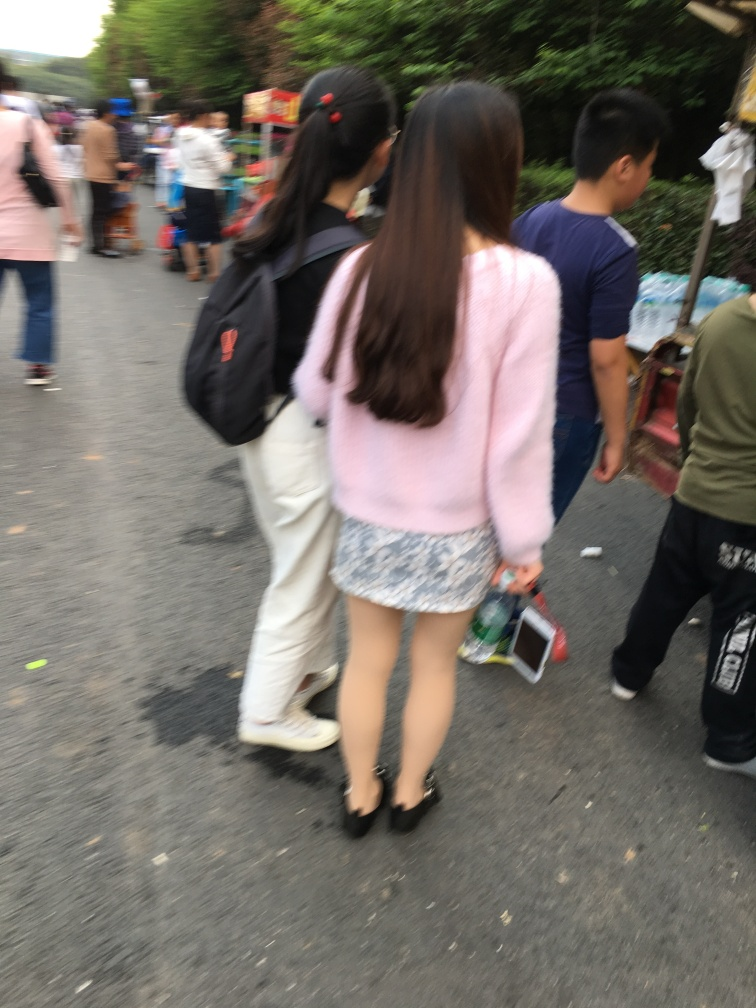Are there any quality issues with this image? Yes, the image is blurry which affects the clarity and detail, potentially impacting the viewer's ability to fully engage with the scene. The motion blur suggests movement and a candid nature to the photograph, characteristic of snapshots taken in dynamic environments such as outdoor markets or streets. 